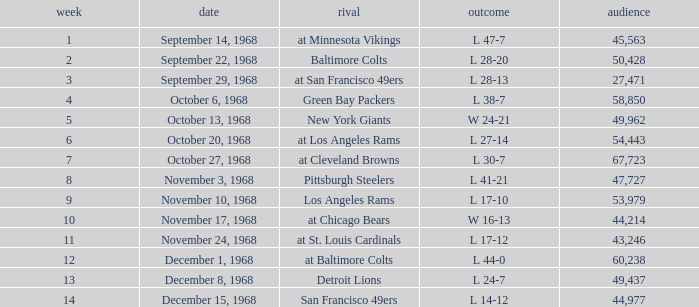Which Week has an Opponent of pittsburgh steelers, and an Attendance larger than 47,727? None. 